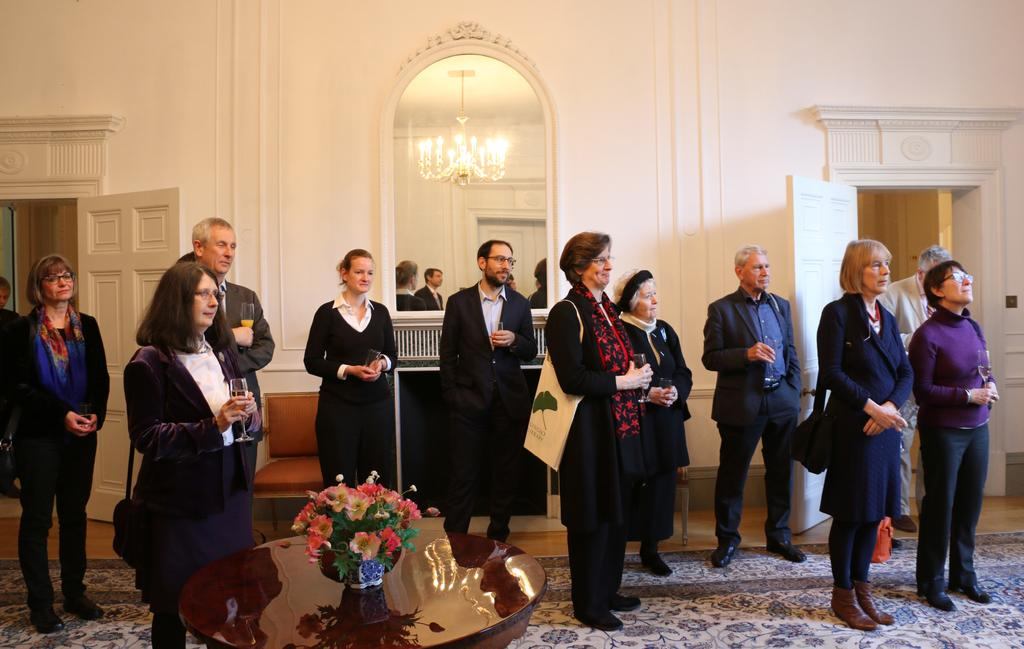What can be found inside the room in the image? There are people in the room. What architectural features are present in the room? There are doors in the room. What decorative item can be seen on a table in the room? There is a flower vase on a table. What is used to reflect the room's contents in the image? There is a mirror in the room that reflects people, doors, and a chandelier. What type of nail is being used to hold the chandelier in the image? There is no nail visible in the image, and the chandelier is not being held up by a nail. What type of war is depicted in the image? There is no depiction of war in the image; it features a room with people, doors, a flower vase, and a mirror. 